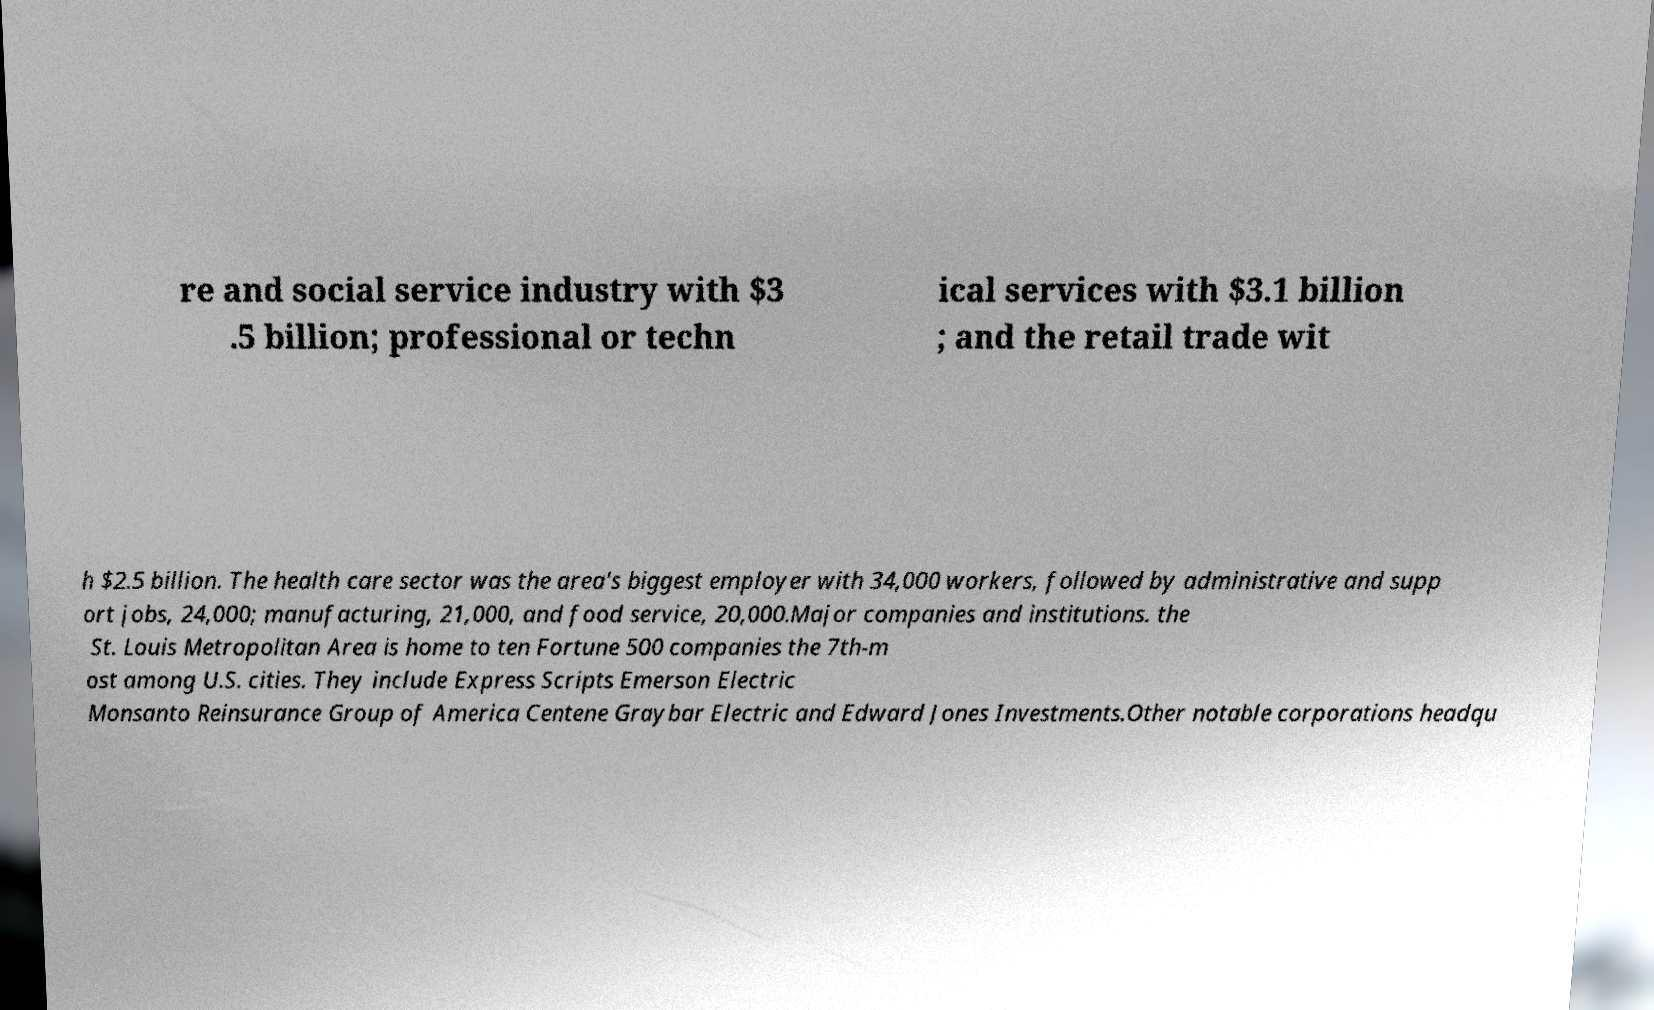Please identify and transcribe the text found in this image. re and social service industry with $3 .5 billion; professional or techn ical services with $3.1 billion ; and the retail trade wit h $2.5 billion. The health care sector was the area's biggest employer with 34,000 workers, followed by administrative and supp ort jobs, 24,000; manufacturing, 21,000, and food service, 20,000.Major companies and institutions. the St. Louis Metropolitan Area is home to ten Fortune 500 companies the 7th-m ost among U.S. cities. They include Express Scripts Emerson Electric Monsanto Reinsurance Group of America Centene Graybar Electric and Edward Jones Investments.Other notable corporations headqu 